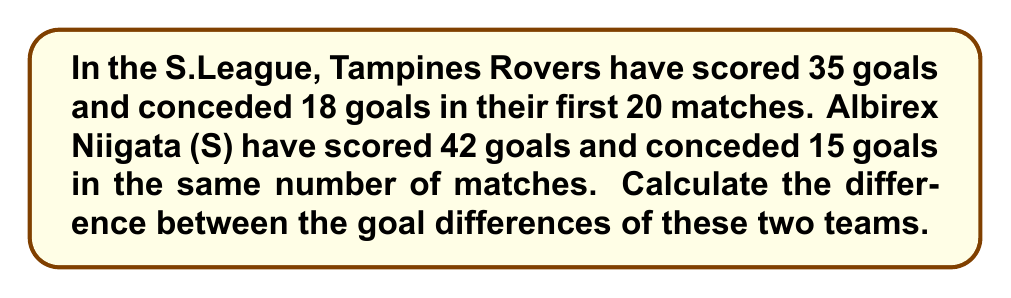Help me with this question. To solve this problem, we need to follow these steps:

1. Calculate the goal difference for Tampines Rovers:
   $$ GD_{Tampines} = \text{Goals Scored} - \text{Goals Conceded} $$
   $$ GD_{Tampines} = 35 - 18 = 17 $$

2. Calculate the goal difference for Albirex Niigata (S):
   $$ GD_{Albirex} = \text{Goals Scored} - \text{Goals Conceded} $$
   $$ GD_{Albirex} = 42 - 15 = 27 $$

3. Calculate the difference between the two goal differences:
   $$ \Delta GD = |GD_{Albirex} - GD_{Tampines}| $$
   $$ \Delta GD = |27 - 17| = 10 $$

The absolute value is used to ensure a positive result, as we're interested in the magnitude of the difference, not which team has the higher goal difference.
Answer: 10 